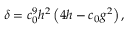Convert formula to latex. <formula><loc_0><loc_0><loc_500><loc_500>\delta = c _ { 0 } ^ { 9 } h ^ { 2 } \left ( 4 h - c _ { 0 } g ^ { 2 } \right ) ,</formula> 